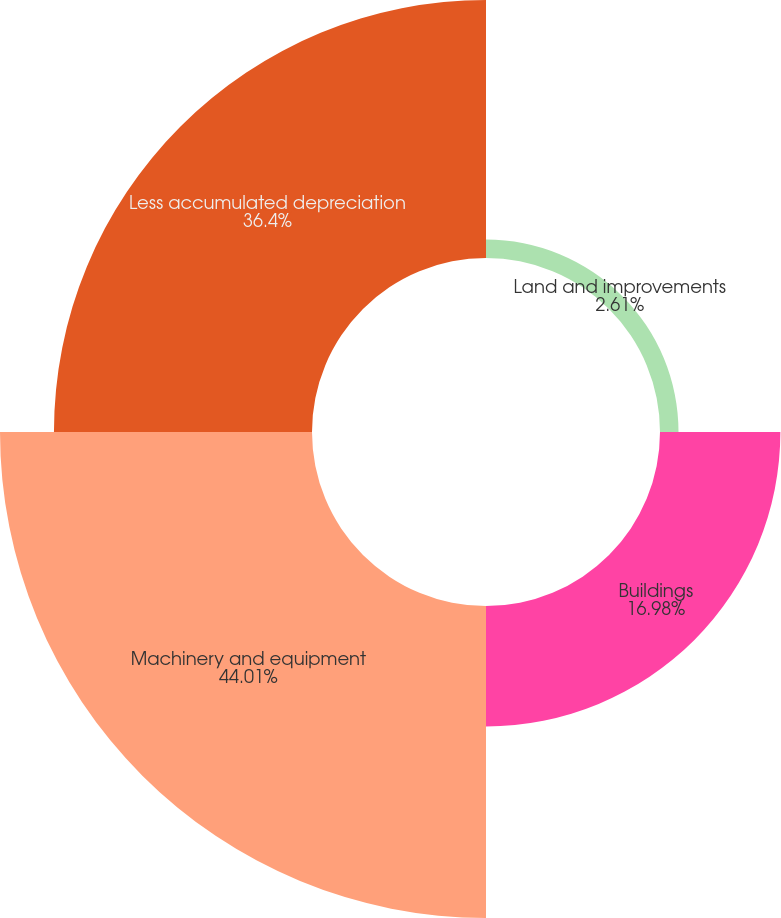Convert chart. <chart><loc_0><loc_0><loc_500><loc_500><pie_chart><fcel>Land and improvements<fcel>Buildings<fcel>Machinery and equipment<fcel>Less accumulated depreciation<nl><fcel>2.61%<fcel>16.98%<fcel>44.01%<fcel>36.4%<nl></chart> 